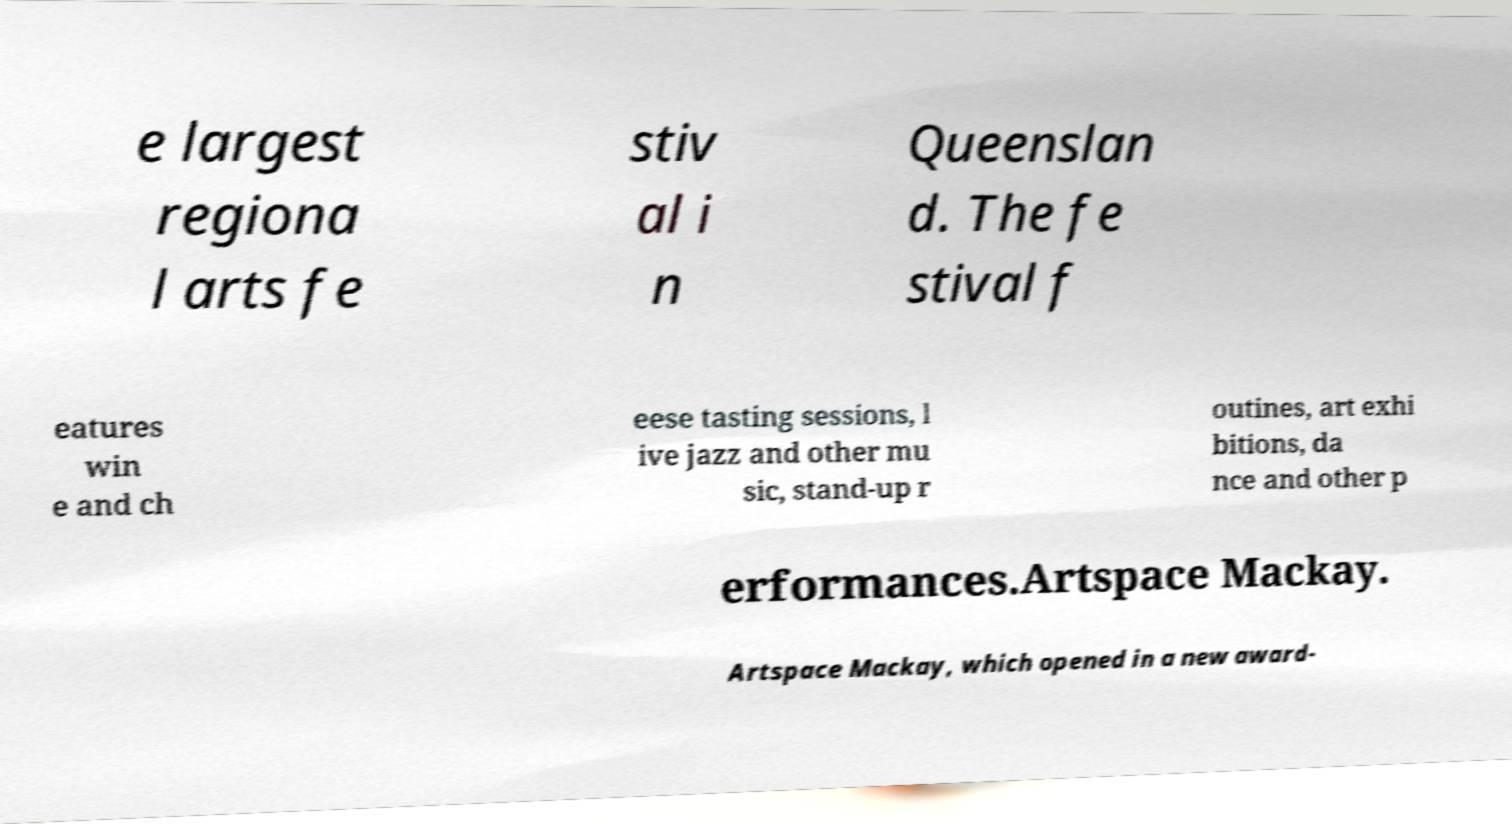Can you read and provide the text displayed in the image?This photo seems to have some interesting text. Can you extract and type it out for me? e largest regiona l arts fe stiv al i n Queenslan d. The fe stival f eatures win e and ch eese tasting sessions, l ive jazz and other mu sic, stand-up r outines, art exhi bitions, da nce and other p erformances.Artspace Mackay. Artspace Mackay, which opened in a new award- 